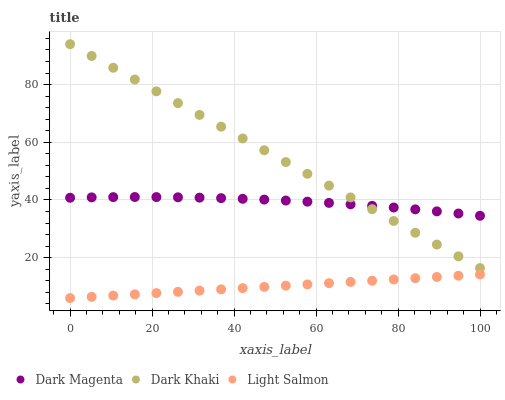Does Light Salmon have the minimum area under the curve?
Answer yes or no. Yes. Does Dark Khaki have the maximum area under the curve?
Answer yes or no. Yes. Does Dark Magenta have the minimum area under the curve?
Answer yes or no. No. Does Dark Magenta have the maximum area under the curve?
Answer yes or no. No. Is Light Salmon the smoothest?
Answer yes or no. Yes. Is Dark Magenta the roughest?
Answer yes or no. Yes. Is Dark Magenta the smoothest?
Answer yes or no. No. Is Light Salmon the roughest?
Answer yes or no. No. Does Light Salmon have the lowest value?
Answer yes or no. Yes. Does Dark Magenta have the lowest value?
Answer yes or no. No. Does Dark Khaki have the highest value?
Answer yes or no. Yes. Does Dark Magenta have the highest value?
Answer yes or no. No. Is Light Salmon less than Dark Magenta?
Answer yes or no. Yes. Is Dark Khaki greater than Light Salmon?
Answer yes or no. Yes. Does Dark Khaki intersect Dark Magenta?
Answer yes or no. Yes. Is Dark Khaki less than Dark Magenta?
Answer yes or no. No. Is Dark Khaki greater than Dark Magenta?
Answer yes or no. No. Does Light Salmon intersect Dark Magenta?
Answer yes or no. No. 